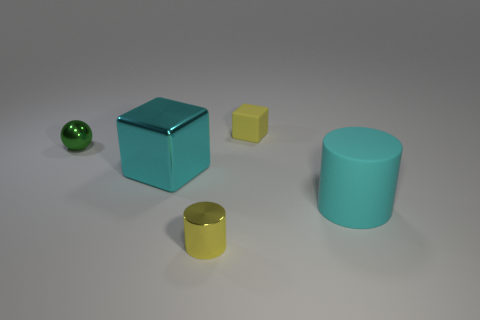Are there any cylinders of the same size as the yellow rubber object?
Make the answer very short. Yes. Is there a metal object that has the same color as the large matte object?
Ensure brevity in your answer.  Yes. How many metallic cubes have the same color as the big matte object?
Ensure brevity in your answer.  1. There is a large metallic thing; is it the same color as the large thing that is right of the small yellow matte block?
Give a very brief answer. Yes. What number of objects are either large gray metal objects or cylinders on the right side of the tiny cube?
Your answer should be compact. 1. What size is the yellow object behind the small metal object behind the tiny shiny cylinder?
Your answer should be very brief. Small. Is the number of cylinders that are on the left side of the big shiny object the same as the number of yellow objects that are in front of the small green ball?
Offer a very short reply. No. There is a shiny object that is behind the cyan block; are there any tiny yellow rubber objects to the right of it?
Your response must be concise. Yes. What is the shape of the cyan thing that is the same material as the small block?
Keep it short and to the point. Cylinder. Are there any other things that are the same color as the tiny rubber object?
Your answer should be compact. Yes. 